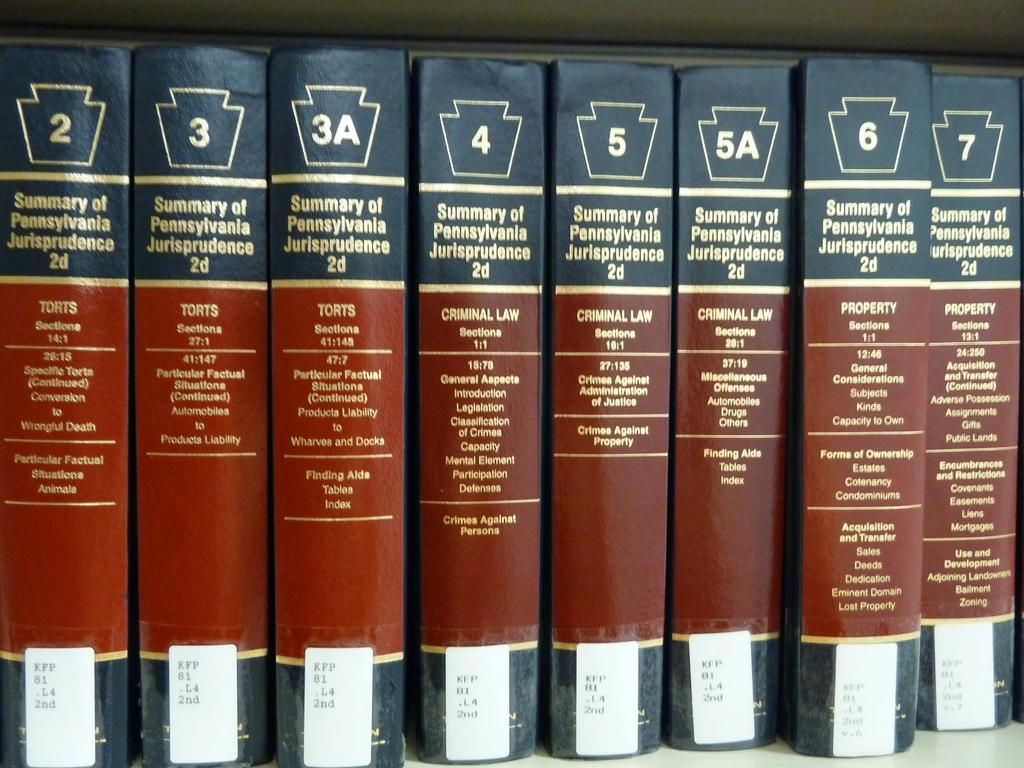Provide a one-sentence caption for the provided image. Eight books based on the Summary of Pennsylvania Jurisprudence. 